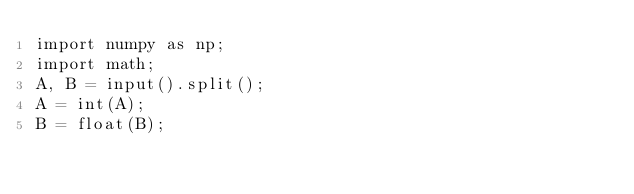<code> <loc_0><loc_0><loc_500><loc_500><_Python_>import numpy as np;
import math;
A, B = input().split();
A = int(A);
B = float(B);



</code> 